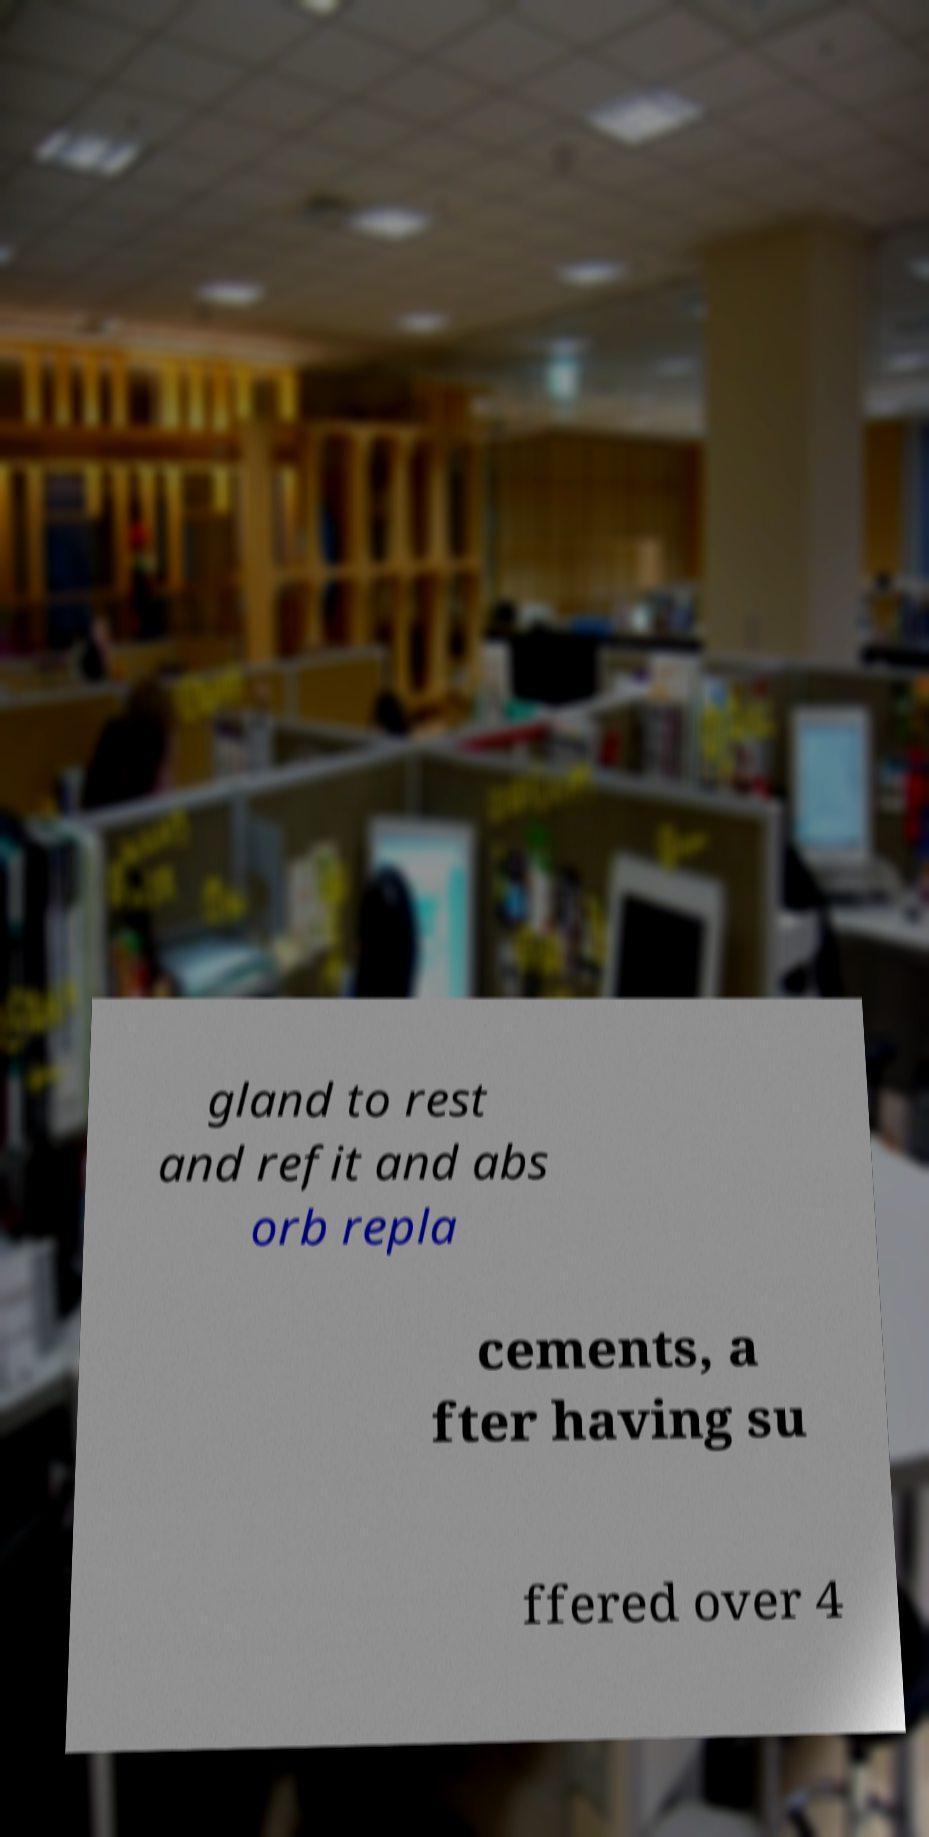Could you extract and type out the text from this image? gland to rest and refit and abs orb repla cements, a fter having su ffered over 4 